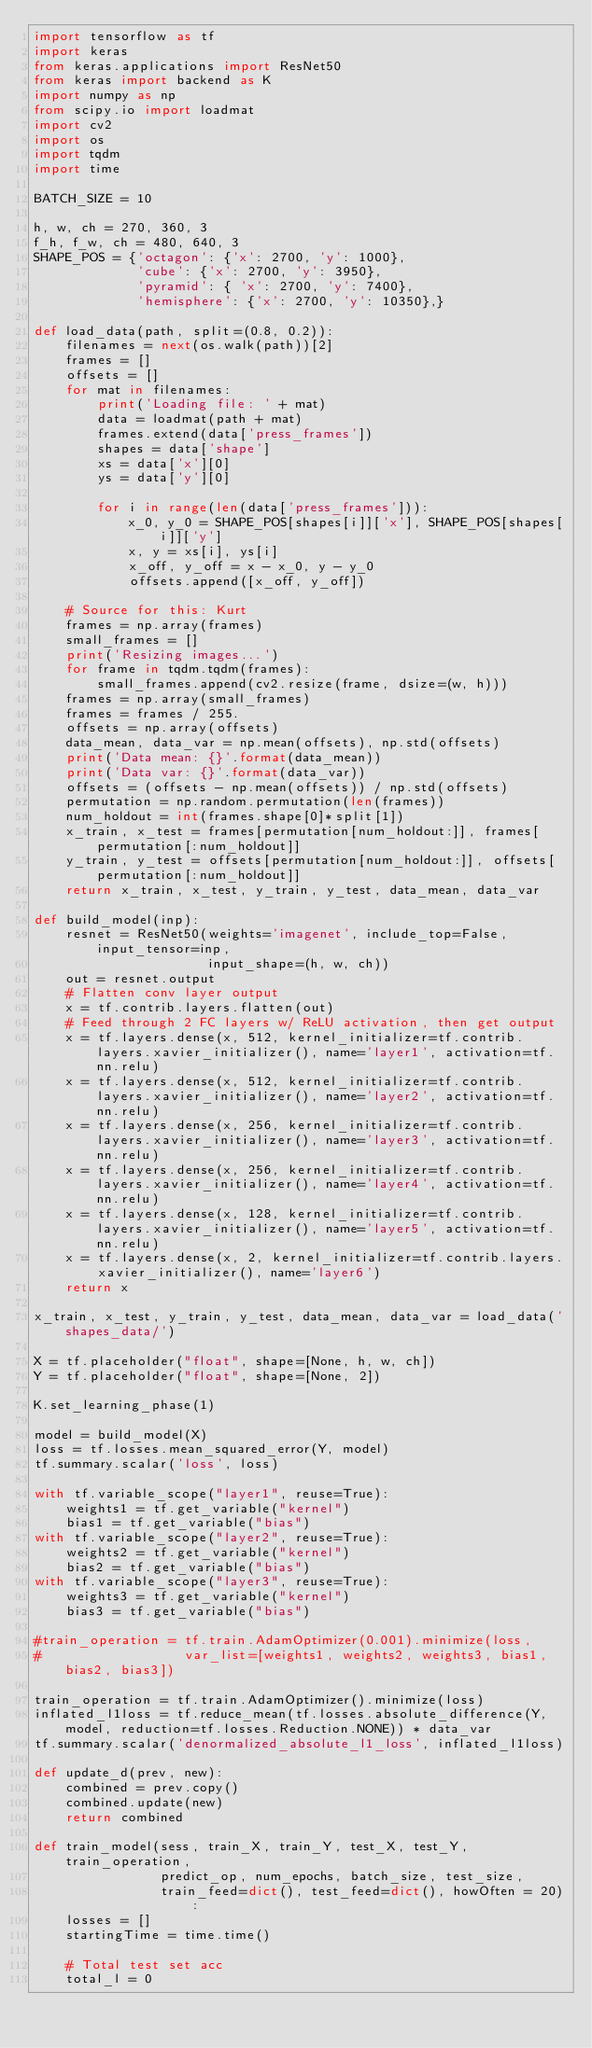<code> <loc_0><loc_0><loc_500><loc_500><_Python_>import tensorflow as tf
import keras 
from keras.applications import ResNet50
from keras import backend as K
import numpy as np
from scipy.io import loadmat
import cv2
import os 
import tqdm
import time

BATCH_SIZE = 10 

h, w, ch = 270, 360, 3
f_h, f_w, ch = 480, 640, 3
SHAPE_POS = {'octagon': {'x': 2700, 'y': 1000},
             'cube': {'x': 2700, 'y': 3950},
             'pyramid': { 'x': 2700, 'y': 7400},
             'hemisphere': {'x': 2700, 'y': 10350},}
             
def load_data(path, split=(0.8, 0.2)):
    filenames = next(os.walk(path))[2]
    frames = []
    offsets = []
    for mat in filenames:
        print('Loading file: ' + mat)
        data = loadmat(path + mat) 
        frames.extend(data['press_frames'])
        shapes = data['shape'] 
        xs = data['x'][0]
        ys = data['y'][0]

        for i in range(len(data['press_frames'])):
            x_0, y_0 = SHAPE_POS[shapes[i]]['x'], SHAPE_POS[shapes[i]]['y']
            x, y = xs[i], ys[i]
            x_off, y_off = x - x_0, y - y_0
            offsets.append([x_off, y_off])

    # Source for this: Kurt 
    frames = np.array(frames)
    small_frames = []
    print('Resizing images...')
    for frame in tqdm.tqdm(frames):
        small_frames.append(cv2.resize(frame, dsize=(w, h)))
    frames = np.array(small_frames)
    frames = frames / 255.
    offsets = np.array(offsets) 
    data_mean, data_var = np.mean(offsets), np.std(offsets)
    print('Data mean: {}'.format(data_mean))
    print('Data var: {}'.format(data_var))
    offsets = (offsets - np.mean(offsets)) / np.std(offsets)
    permutation = np.random.permutation(len(frames))
    num_holdout = int(frames.shape[0]*split[1])
    x_train, x_test = frames[permutation[num_holdout:]], frames[permutation[:num_holdout]]
    y_train, y_test = offsets[permutation[num_holdout:]], offsets[permutation[:num_holdout]]
    return x_train, x_test, y_train, y_test, data_mean, data_var

def build_model(inp):
    resnet = ResNet50(weights='imagenet', include_top=False, input_tensor=inp, 
                      input_shape=(h, w, ch))
    out = resnet.output
    # Flatten conv layer output
    x = tf.contrib.layers.flatten(out)
    # Feed through 2 FC layers w/ ReLU activation, then get output
    x = tf.layers.dense(x, 512, kernel_initializer=tf.contrib.layers.xavier_initializer(), name='layer1', activation=tf.nn.relu)
    x = tf.layers.dense(x, 512, kernel_initializer=tf.contrib.layers.xavier_initializer(), name='layer2', activation=tf.nn.relu)
    x = tf.layers.dense(x, 256, kernel_initializer=tf.contrib.layers.xavier_initializer(), name='layer3', activation=tf.nn.relu)
    x = tf.layers.dense(x, 256, kernel_initializer=tf.contrib.layers.xavier_initializer(), name='layer4', activation=tf.nn.relu)
    x = tf.layers.dense(x, 128, kernel_initializer=tf.contrib.layers.xavier_initializer(), name='layer5', activation=tf.nn.relu)
    x = tf.layers.dense(x, 2, kernel_initializer=tf.contrib.layers.xavier_initializer(), name='layer6')
    return x 

x_train, x_test, y_train, y_test, data_mean, data_var = load_data('shapes_data/')

X = tf.placeholder("float", shape=[None, h, w, ch])
Y = tf.placeholder("float", shape=[None, 2])

K.set_learning_phase(1)

model = build_model(X)
loss = tf.losses.mean_squared_error(Y, model)
tf.summary.scalar('loss', loss)

with tf.variable_scope("layer1", reuse=True):
    weights1 = tf.get_variable("kernel")
    bias1 = tf.get_variable("bias") 
with tf.variable_scope("layer2", reuse=True):
    weights2 = tf.get_variable("kernel")
    bias2 = tf.get_variable("bias") 
with tf.variable_scope("layer3", reuse=True):
    weights3 = tf.get_variable("kernel")
    bias3 = tf.get_variable("bias") 

#train_operation = tf.train.AdamOptimizer(0.001).minimize(loss, 
#                  var_list=[weights1, weights2, weights3, bias1, bias2, bias3])

train_operation = tf.train.AdamOptimizer().minimize(loss)
inflated_l1loss = tf.reduce_mean(tf.losses.absolute_difference(Y, model, reduction=tf.losses.Reduction.NONE)) * data_var 
tf.summary.scalar('denormalized_absolute_l1_loss', inflated_l1loss)

def update_d(prev, new):
    combined = prev.copy()
    combined.update(new)
    return combined

def train_model(sess, train_X, train_Y, test_X, test_Y, train_operation,
                predict_op, num_epochs, batch_size, test_size,
                train_feed=dict(), test_feed=dict(), howOften = 20):
    losses = []
    startingTime = time.time()
    
    # Total test set acc 
    total_l = 0</code> 